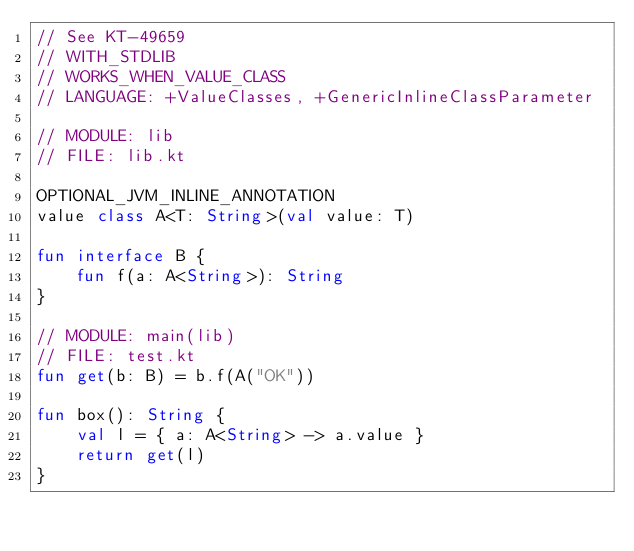Convert code to text. <code><loc_0><loc_0><loc_500><loc_500><_Kotlin_>// See KT-49659
// WITH_STDLIB
// WORKS_WHEN_VALUE_CLASS
// LANGUAGE: +ValueClasses, +GenericInlineClassParameter

// MODULE: lib
// FILE: lib.kt

OPTIONAL_JVM_INLINE_ANNOTATION
value class A<T: String>(val value: T)

fun interface B {
    fun f(a: A<String>): String
}

// MODULE: main(lib)
// FILE: test.kt
fun get(b: B) = b.f(A("OK"))

fun box(): String {
    val l = { a: A<String> -> a.value }
    return get(l)
}
</code> 